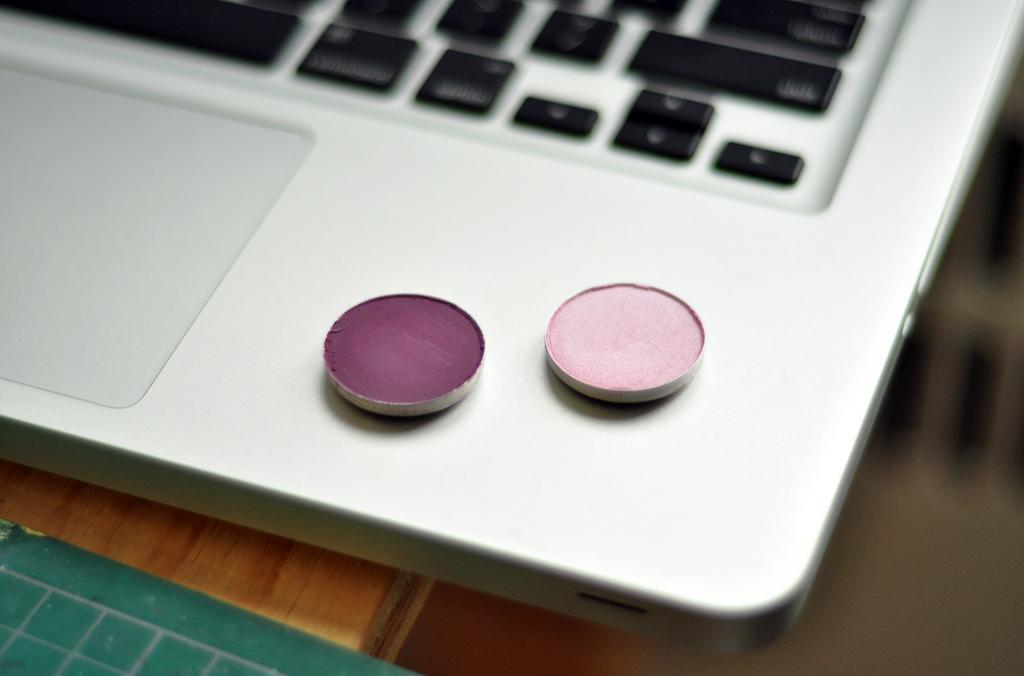How would you summarize this image in a sentence or two? In this image there is a laptop towards the top of the image, there are objects on the laptop, there is a wooden object that looks like a table, there is an object on the table towards the bottom of the image, the right side of the image is blurred. 